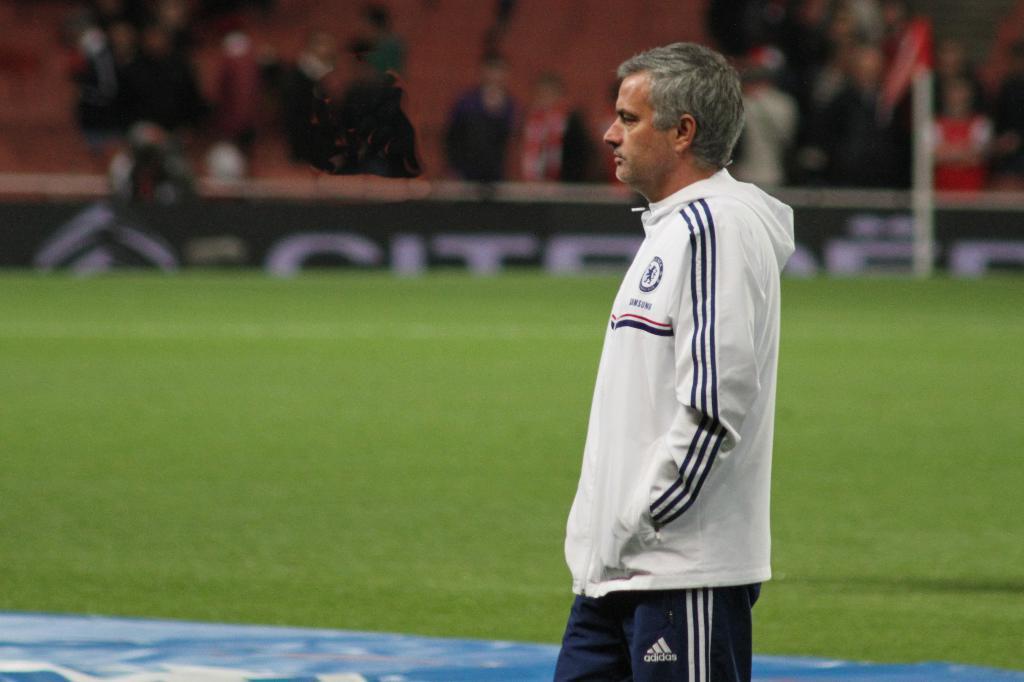Can you describe this image briefly? In this picture we can see a man and in the background we can see the grass, group of people and it is blurry. 